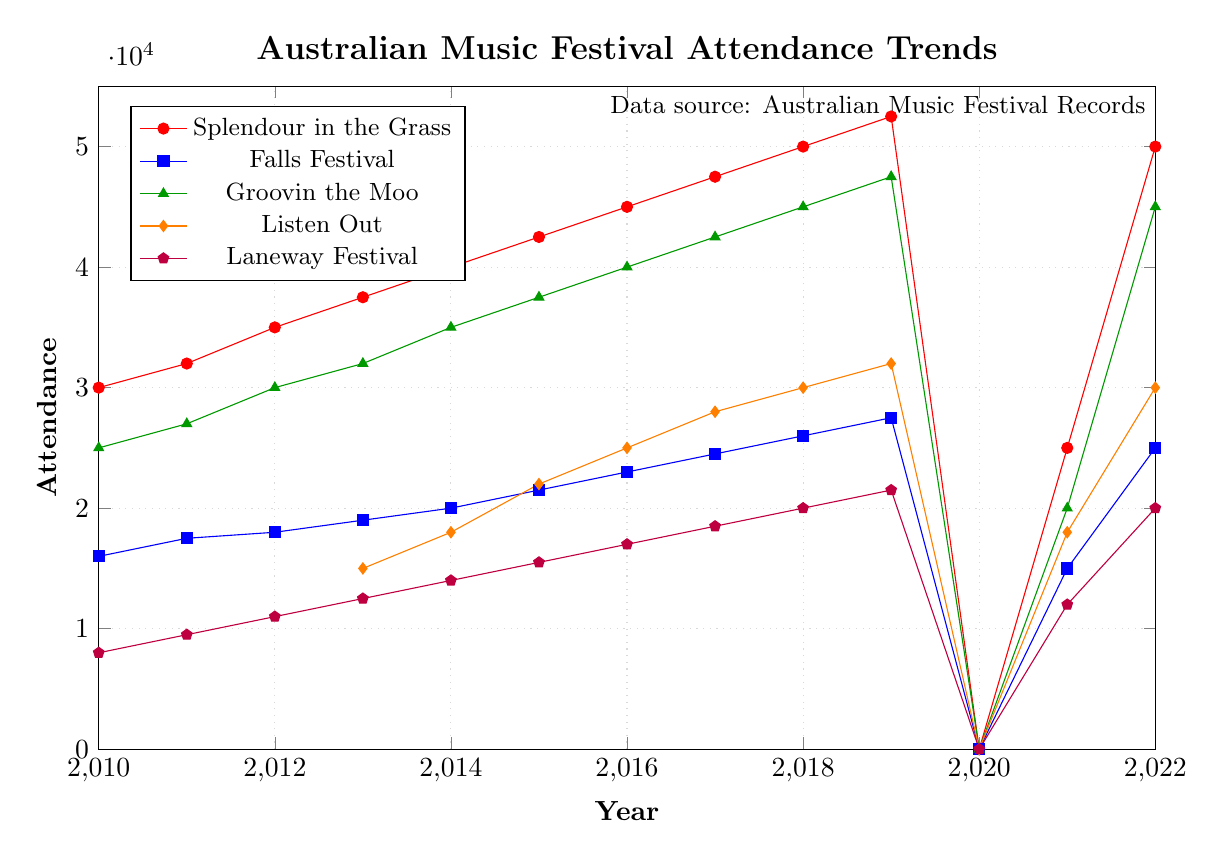What's the trend in attendance for Splendour in the Grass from 2010 to 2019? The attendance for Splendour in the Grass increases almost steadily each year from 30,000 in 2010 to 52,500 in 2019.
Answer: Increasing trend How did the attendance for Groovin the Moo change between 2013 and 2019? The attendance for Groovin the Moo increased from 32,000 in 2013 to 47,500 in 2019.
Answer: Increased by 15,500 Which festival had the highest attendance in 2022? In 2022, Splendour in the Grass and Groovin the Moo both had the highest attendance of 50,000.
Answer: Splendour in the Grass and Groovin the Moo Did any festival have zero attendance in 2020, and if so, which ones? Yes, all listed festivals (Splendour in the Grass, Falls Festival, Groovin the Moo, Listen Out, Laneway Festival) had zero attendance in 2020.
Answer: All festivals What is the difference in attendance between the highest and lowest attended festival in 2018? In 2018, the highest attendance was for Splendour in the Grass at 50,000, and the lowest was for Laneway Festival at 20,000. The difference is 50,000 - 20,000 = 30,000.
Answer: 30,000 Compare the attendance trends of Listen Out and Laneway Festival from 2013 to 2019. Both Listen Out and Laneway Festival show a steady increase in attendance from 2013 to 2019, with Listen Out going from 15,000 to 32,000 and Laneway Festival from 12,500 to 21,500.
Answer: Both increased steadily Which festivals rebounded to their pre-2020 attendance levels by 2022? By 2022, Splendour in the Grass and Groovin the Moo rebounded to their pre-2020 attendance levels, reaching 50,000 and 45,000, respectively.
Answer: Splendour in the Grass and Groovin the Moo How many festivals had an attendance of 25,000 or more in 2021? In 2021, only Splendour in the Grass had an attendance of 25,000 or more, with an attendance of 25,000.
Answer: One festival What was the attendance for Falls Festival in 2016, and how does it compare to its attendance in 2018? In 2016, Falls Festival had an attendance of 23,000, and in 2018, it increased to 26,000. This shows a growth of 3,000.
Answer: Increased by 3,000 